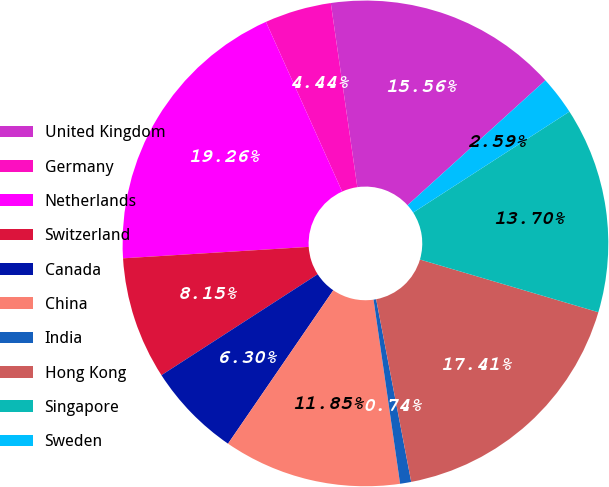<chart> <loc_0><loc_0><loc_500><loc_500><pie_chart><fcel>United Kingdom<fcel>Germany<fcel>Netherlands<fcel>Switzerland<fcel>Canada<fcel>China<fcel>India<fcel>Hong Kong<fcel>Singapore<fcel>Sweden<nl><fcel>15.56%<fcel>4.44%<fcel>19.26%<fcel>8.15%<fcel>6.3%<fcel>11.85%<fcel>0.74%<fcel>17.41%<fcel>13.7%<fcel>2.59%<nl></chart> 